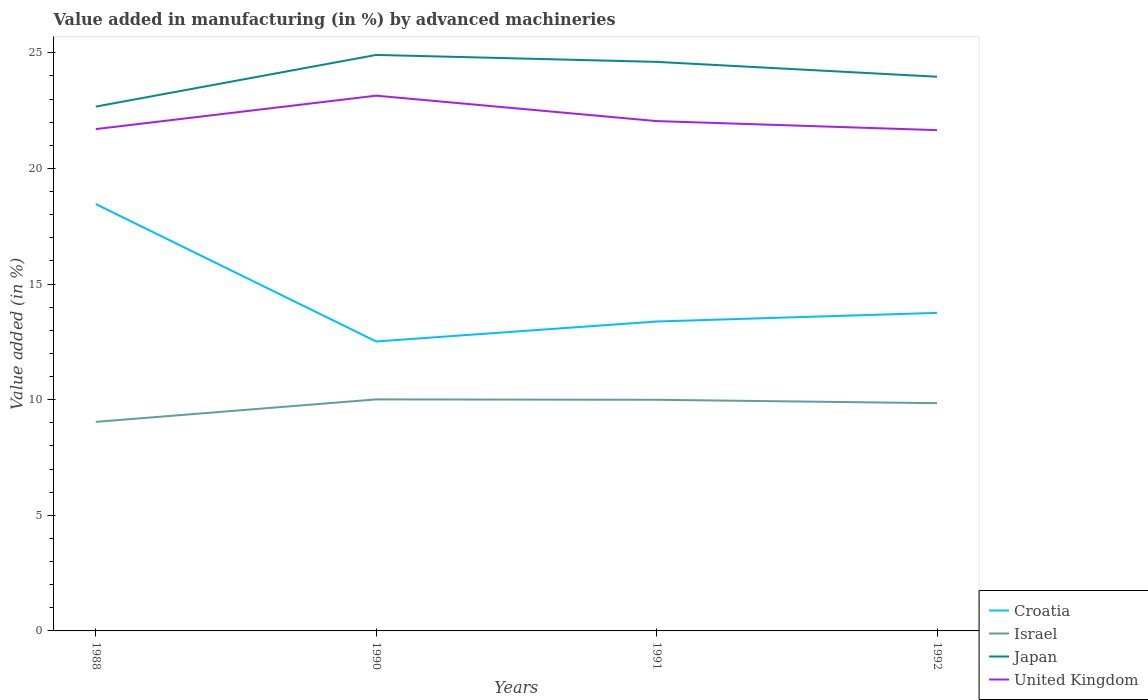How many different coloured lines are there?
Provide a succinct answer. 4. Is the number of lines equal to the number of legend labels?
Your answer should be very brief. Yes. Across all years, what is the maximum percentage of value added in manufacturing by advanced machineries in Israel?
Offer a terse response. 9.04. In which year was the percentage of value added in manufacturing by advanced machineries in Japan maximum?
Provide a short and direct response. 1988. What is the total percentage of value added in manufacturing by advanced machineries in United Kingdom in the graph?
Provide a short and direct response. 1.49. What is the difference between the highest and the second highest percentage of value added in manufacturing by advanced machineries in Israel?
Your answer should be very brief. 0.97. Is the percentage of value added in manufacturing by advanced machineries in Israel strictly greater than the percentage of value added in manufacturing by advanced machineries in United Kingdom over the years?
Provide a succinct answer. Yes. Does the graph contain grids?
Your response must be concise. No. Where does the legend appear in the graph?
Offer a very short reply. Bottom right. How many legend labels are there?
Keep it short and to the point. 4. What is the title of the graph?
Your answer should be compact. Value added in manufacturing (in %) by advanced machineries. Does "Nicaragua" appear as one of the legend labels in the graph?
Ensure brevity in your answer.  No. What is the label or title of the Y-axis?
Keep it short and to the point. Value added (in %). What is the Value added (in %) in Croatia in 1988?
Provide a short and direct response. 18.46. What is the Value added (in %) of Israel in 1988?
Your answer should be compact. 9.04. What is the Value added (in %) in Japan in 1988?
Your answer should be very brief. 22.68. What is the Value added (in %) in United Kingdom in 1988?
Your response must be concise. 21.7. What is the Value added (in %) of Croatia in 1990?
Provide a succinct answer. 12.52. What is the Value added (in %) in Israel in 1990?
Ensure brevity in your answer.  10.01. What is the Value added (in %) of Japan in 1990?
Your response must be concise. 24.91. What is the Value added (in %) in United Kingdom in 1990?
Offer a terse response. 23.15. What is the Value added (in %) in Croatia in 1991?
Your answer should be compact. 13.38. What is the Value added (in %) in Israel in 1991?
Provide a succinct answer. 10. What is the Value added (in %) in Japan in 1991?
Provide a short and direct response. 24.61. What is the Value added (in %) in United Kingdom in 1991?
Provide a succinct answer. 22.05. What is the Value added (in %) in Croatia in 1992?
Your answer should be very brief. 13.76. What is the Value added (in %) in Israel in 1992?
Provide a short and direct response. 9.85. What is the Value added (in %) of Japan in 1992?
Ensure brevity in your answer.  23.97. What is the Value added (in %) in United Kingdom in 1992?
Your answer should be very brief. 21.66. Across all years, what is the maximum Value added (in %) of Croatia?
Provide a short and direct response. 18.46. Across all years, what is the maximum Value added (in %) of Israel?
Your answer should be compact. 10.01. Across all years, what is the maximum Value added (in %) of Japan?
Make the answer very short. 24.91. Across all years, what is the maximum Value added (in %) in United Kingdom?
Your answer should be compact. 23.15. Across all years, what is the minimum Value added (in %) in Croatia?
Ensure brevity in your answer.  12.52. Across all years, what is the minimum Value added (in %) of Israel?
Your answer should be very brief. 9.04. Across all years, what is the minimum Value added (in %) of Japan?
Offer a very short reply. 22.68. Across all years, what is the minimum Value added (in %) of United Kingdom?
Provide a short and direct response. 21.66. What is the total Value added (in %) of Croatia in the graph?
Provide a short and direct response. 58.12. What is the total Value added (in %) of Israel in the graph?
Keep it short and to the point. 38.9. What is the total Value added (in %) of Japan in the graph?
Offer a very short reply. 96.17. What is the total Value added (in %) of United Kingdom in the graph?
Provide a short and direct response. 88.56. What is the difference between the Value added (in %) in Croatia in 1988 and that in 1990?
Provide a short and direct response. 5.94. What is the difference between the Value added (in %) in Israel in 1988 and that in 1990?
Make the answer very short. -0.97. What is the difference between the Value added (in %) in Japan in 1988 and that in 1990?
Offer a very short reply. -2.23. What is the difference between the Value added (in %) in United Kingdom in 1988 and that in 1990?
Ensure brevity in your answer.  -1.45. What is the difference between the Value added (in %) in Croatia in 1988 and that in 1991?
Make the answer very short. 5.08. What is the difference between the Value added (in %) of Israel in 1988 and that in 1991?
Your answer should be compact. -0.96. What is the difference between the Value added (in %) of Japan in 1988 and that in 1991?
Your answer should be compact. -1.93. What is the difference between the Value added (in %) of United Kingdom in 1988 and that in 1991?
Ensure brevity in your answer.  -0.35. What is the difference between the Value added (in %) in Croatia in 1988 and that in 1992?
Ensure brevity in your answer.  4.71. What is the difference between the Value added (in %) in Israel in 1988 and that in 1992?
Your answer should be very brief. -0.81. What is the difference between the Value added (in %) in Japan in 1988 and that in 1992?
Offer a terse response. -1.29. What is the difference between the Value added (in %) in United Kingdom in 1988 and that in 1992?
Your response must be concise. 0.04. What is the difference between the Value added (in %) of Croatia in 1990 and that in 1991?
Your answer should be very brief. -0.86. What is the difference between the Value added (in %) in Israel in 1990 and that in 1991?
Make the answer very short. 0.02. What is the difference between the Value added (in %) of Japan in 1990 and that in 1991?
Make the answer very short. 0.3. What is the difference between the Value added (in %) of United Kingdom in 1990 and that in 1991?
Offer a terse response. 1.1. What is the difference between the Value added (in %) of Croatia in 1990 and that in 1992?
Give a very brief answer. -1.24. What is the difference between the Value added (in %) in Israel in 1990 and that in 1992?
Your response must be concise. 0.16. What is the difference between the Value added (in %) in Japan in 1990 and that in 1992?
Your response must be concise. 0.94. What is the difference between the Value added (in %) of United Kingdom in 1990 and that in 1992?
Your answer should be very brief. 1.49. What is the difference between the Value added (in %) of Croatia in 1991 and that in 1992?
Provide a short and direct response. -0.37. What is the difference between the Value added (in %) in Israel in 1991 and that in 1992?
Provide a short and direct response. 0.15. What is the difference between the Value added (in %) of Japan in 1991 and that in 1992?
Offer a terse response. 0.64. What is the difference between the Value added (in %) of United Kingdom in 1991 and that in 1992?
Give a very brief answer. 0.39. What is the difference between the Value added (in %) in Croatia in 1988 and the Value added (in %) in Israel in 1990?
Keep it short and to the point. 8.45. What is the difference between the Value added (in %) of Croatia in 1988 and the Value added (in %) of Japan in 1990?
Keep it short and to the point. -6.45. What is the difference between the Value added (in %) in Croatia in 1988 and the Value added (in %) in United Kingdom in 1990?
Offer a very short reply. -4.69. What is the difference between the Value added (in %) in Israel in 1988 and the Value added (in %) in Japan in 1990?
Provide a short and direct response. -15.87. What is the difference between the Value added (in %) in Israel in 1988 and the Value added (in %) in United Kingdom in 1990?
Provide a succinct answer. -14.11. What is the difference between the Value added (in %) of Japan in 1988 and the Value added (in %) of United Kingdom in 1990?
Your answer should be compact. -0.47. What is the difference between the Value added (in %) in Croatia in 1988 and the Value added (in %) in Israel in 1991?
Offer a terse response. 8.46. What is the difference between the Value added (in %) in Croatia in 1988 and the Value added (in %) in Japan in 1991?
Ensure brevity in your answer.  -6.15. What is the difference between the Value added (in %) in Croatia in 1988 and the Value added (in %) in United Kingdom in 1991?
Offer a terse response. -3.59. What is the difference between the Value added (in %) in Israel in 1988 and the Value added (in %) in Japan in 1991?
Keep it short and to the point. -15.57. What is the difference between the Value added (in %) in Israel in 1988 and the Value added (in %) in United Kingdom in 1991?
Your answer should be very brief. -13.01. What is the difference between the Value added (in %) of Japan in 1988 and the Value added (in %) of United Kingdom in 1991?
Your answer should be very brief. 0.63. What is the difference between the Value added (in %) in Croatia in 1988 and the Value added (in %) in Israel in 1992?
Your answer should be very brief. 8.61. What is the difference between the Value added (in %) in Croatia in 1988 and the Value added (in %) in Japan in 1992?
Your response must be concise. -5.51. What is the difference between the Value added (in %) in Croatia in 1988 and the Value added (in %) in United Kingdom in 1992?
Provide a succinct answer. -3.2. What is the difference between the Value added (in %) in Israel in 1988 and the Value added (in %) in Japan in 1992?
Provide a short and direct response. -14.93. What is the difference between the Value added (in %) in Israel in 1988 and the Value added (in %) in United Kingdom in 1992?
Give a very brief answer. -12.62. What is the difference between the Value added (in %) of Japan in 1988 and the Value added (in %) of United Kingdom in 1992?
Offer a terse response. 1.02. What is the difference between the Value added (in %) in Croatia in 1990 and the Value added (in %) in Israel in 1991?
Ensure brevity in your answer.  2.52. What is the difference between the Value added (in %) of Croatia in 1990 and the Value added (in %) of Japan in 1991?
Provide a succinct answer. -12.09. What is the difference between the Value added (in %) in Croatia in 1990 and the Value added (in %) in United Kingdom in 1991?
Your answer should be compact. -9.53. What is the difference between the Value added (in %) of Israel in 1990 and the Value added (in %) of Japan in 1991?
Give a very brief answer. -14.6. What is the difference between the Value added (in %) of Israel in 1990 and the Value added (in %) of United Kingdom in 1991?
Your response must be concise. -12.04. What is the difference between the Value added (in %) of Japan in 1990 and the Value added (in %) of United Kingdom in 1991?
Your answer should be very brief. 2.86. What is the difference between the Value added (in %) of Croatia in 1990 and the Value added (in %) of Israel in 1992?
Make the answer very short. 2.67. What is the difference between the Value added (in %) in Croatia in 1990 and the Value added (in %) in Japan in 1992?
Offer a very short reply. -11.45. What is the difference between the Value added (in %) in Croatia in 1990 and the Value added (in %) in United Kingdom in 1992?
Your answer should be very brief. -9.14. What is the difference between the Value added (in %) of Israel in 1990 and the Value added (in %) of Japan in 1992?
Offer a very short reply. -13.95. What is the difference between the Value added (in %) in Israel in 1990 and the Value added (in %) in United Kingdom in 1992?
Your answer should be very brief. -11.64. What is the difference between the Value added (in %) in Japan in 1990 and the Value added (in %) in United Kingdom in 1992?
Ensure brevity in your answer.  3.25. What is the difference between the Value added (in %) in Croatia in 1991 and the Value added (in %) in Israel in 1992?
Your answer should be compact. 3.53. What is the difference between the Value added (in %) of Croatia in 1991 and the Value added (in %) of Japan in 1992?
Make the answer very short. -10.59. What is the difference between the Value added (in %) in Croatia in 1991 and the Value added (in %) in United Kingdom in 1992?
Your answer should be compact. -8.28. What is the difference between the Value added (in %) of Israel in 1991 and the Value added (in %) of Japan in 1992?
Ensure brevity in your answer.  -13.97. What is the difference between the Value added (in %) in Israel in 1991 and the Value added (in %) in United Kingdom in 1992?
Give a very brief answer. -11.66. What is the difference between the Value added (in %) in Japan in 1991 and the Value added (in %) in United Kingdom in 1992?
Make the answer very short. 2.95. What is the average Value added (in %) in Croatia per year?
Provide a short and direct response. 14.53. What is the average Value added (in %) in Israel per year?
Make the answer very short. 9.73. What is the average Value added (in %) in Japan per year?
Ensure brevity in your answer.  24.04. What is the average Value added (in %) of United Kingdom per year?
Offer a very short reply. 22.14. In the year 1988, what is the difference between the Value added (in %) of Croatia and Value added (in %) of Israel?
Provide a short and direct response. 9.42. In the year 1988, what is the difference between the Value added (in %) of Croatia and Value added (in %) of Japan?
Offer a very short reply. -4.21. In the year 1988, what is the difference between the Value added (in %) in Croatia and Value added (in %) in United Kingdom?
Your answer should be very brief. -3.24. In the year 1988, what is the difference between the Value added (in %) in Israel and Value added (in %) in Japan?
Provide a short and direct response. -13.64. In the year 1988, what is the difference between the Value added (in %) of Israel and Value added (in %) of United Kingdom?
Provide a short and direct response. -12.66. In the year 1988, what is the difference between the Value added (in %) of Japan and Value added (in %) of United Kingdom?
Make the answer very short. 0.97. In the year 1990, what is the difference between the Value added (in %) of Croatia and Value added (in %) of Israel?
Keep it short and to the point. 2.5. In the year 1990, what is the difference between the Value added (in %) of Croatia and Value added (in %) of Japan?
Give a very brief answer. -12.39. In the year 1990, what is the difference between the Value added (in %) of Croatia and Value added (in %) of United Kingdom?
Provide a short and direct response. -10.63. In the year 1990, what is the difference between the Value added (in %) of Israel and Value added (in %) of Japan?
Give a very brief answer. -14.9. In the year 1990, what is the difference between the Value added (in %) in Israel and Value added (in %) in United Kingdom?
Provide a short and direct response. -13.14. In the year 1990, what is the difference between the Value added (in %) in Japan and Value added (in %) in United Kingdom?
Make the answer very short. 1.76. In the year 1991, what is the difference between the Value added (in %) of Croatia and Value added (in %) of Israel?
Ensure brevity in your answer.  3.38. In the year 1991, what is the difference between the Value added (in %) of Croatia and Value added (in %) of Japan?
Provide a succinct answer. -11.23. In the year 1991, what is the difference between the Value added (in %) in Croatia and Value added (in %) in United Kingdom?
Your answer should be very brief. -8.67. In the year 1991, what is the difference between the Value added (in %) in Israel and Value added (in %) in Japan?
Keep it short and to the point. -14.61. In the year 1991, what is the difference between the Value added (in %) of Israel and Value added (in %) of United Kingdom?
Your response must be concise. -12.05. In the year 1991, what is the difference between the Value added (in %) of Japan and Value added (in %) of United Kingdom?
Provide a short and direct response. 2.56. In the year 1992, what is the difference between the Value added (in %) of Croatia and Value added (in %) of Israel?
Offer a terse response. 3.91. In the year 1992, what is the difference between the Value added (in %) in Croatia and Value added (in %) in Japan?
Offer a terse response. -10.21. In the year 1992, what is the difference between the Value added (in %) in Croatia and Value added (in %) in United Kingdom?
Your response must be concise. -7.9. In the year 1992, what is the difference between the Value added (in %) of Israel and Value added (in %) of Japan?
Your response must be concise. -14.12. In the year 1992, what is the difference between the Value added (in %) of Israel and Value added (in %) of United Kingdom?
Ensure brevity in your answer.  -11.81. In the year 1992, what is the difference between the Value added (in %) in Japan and Value added (in %) in United Kingdom?
Your answer should be compact. 2.31. What is the ratio of the Value added (in %) of Croatia in 1988 to that in 1990?
Keep it short and to the point. 1.47. What is the ratio of the Value added (in %) in Israel in 1988 to that in 1990?
Make the answer very short. 0.9. What is the ratio of the Value added (in %) in Japan in 1988 to that in 1990?
Your answer should be very brief. 0.91. What is the ratio of the Value added (in %) of Croatia in 1988 to that in 1991?
Your response must be concise. 1.38. What is the ratio of the Value added (in %) in Israel in 1988 to that in 1991?
Ensure brevity in your answer.  0.9. What is the ratio of the Value added (in %) of Japan in 1988 to that in 1991?
Your response must be concise. 0.92. What is the ratio of the Value added (in %) in United Kingdom in 1988 to that in 1991?
Give a very brief answer. 0.98. What is the ratio of the Value added (in %) in Croatia in 1988 to that in 1992?
Your response must be concise. 1.34. What is the ratio of the Value added (in %) of Israel in 1988 to that in 1992?
Offer a terse response. 0.92. What is the ratio of the Value added (in %) in Japan in 1988 to that in 1992?
Offer a terse response. 0.95. What is the ratio of the Value added (in %) of United Kingdom in 1988 to that in 1992?
Offer a terse response. 1. What is the ratio of the Value added (in %) in Croatia in 1990 to that in 1991?
Offer a very short reply. 0.94. What is the ratio of the Value added (in %) of Japan in 1990 to that in 1991?
Provide a short and direct response. 1.01. What is the ratio of the Value added (in %) of United Kingdom in 1990 to that in 1991?
Give a very brief answer. 1.05. What is the ratio of the Value added (in %) of Croatia in 1990 to that in 1992?
Offer a very short reply. 0.91. What is the ratio of the Value added (in %) of Israel in 1990 to that in 1992?
Keep it short and to the point. 1.02. What is the ratio of the Value added (in %) of Japan in 1990 to that in 1992?
Offer a terse response. 1.04. What is the ratio of the Value added (in %) in United Kingdom in 1990 to that in 1992?
Ensure brevity in your answer.  1.07. What is the ratio of the Value added (in %) of Croatia in 1991 to that in 1992?
Offer a terse response. 0.97. What is the ratio of the Value added (in %) of Israel in 1991 to that in 1992?
Your answer should be very brief. 1.01. What is the ratio of the Value added (in %) in Japan in 1991 to that in 1992?
Provide a short and direct response. 1.03. What is the ratio of the Value added (in %) of United Kingdom in 1991 to that in 1992?
Offer a very short reply. 1.02. What is the difference between the highest and the second highest Value added (in %) of Croatia?
Provide a succinct answer. 4.71. What is the difference between the highest and the second highest Value added (in %) of Israel?
Make the answer very short. 0.02. What is the difference between the highest and the second highest Value added (in %) in Japan?
Offer a terse response. 0.3. What is the difference between the highest and the second highest Value added (in %) in United Kingdom?
Your answer should be very brief. 1.1. What is the difference between the highest and the lowest Value added (in %) of Croatia?
Offer a terse response. 5.94. What is the difference between the highest and the lowest Value added (in %) in Israel?
Offer a terse response. 0.97. What is the difference between the highest and the lowest Value added (in %) of Japan?
Your response must be concise. 2.23. What is the difference between the highest and the lowest Value added (in %) of United Kingdom?
Provide a short and direct response. 1.49. 